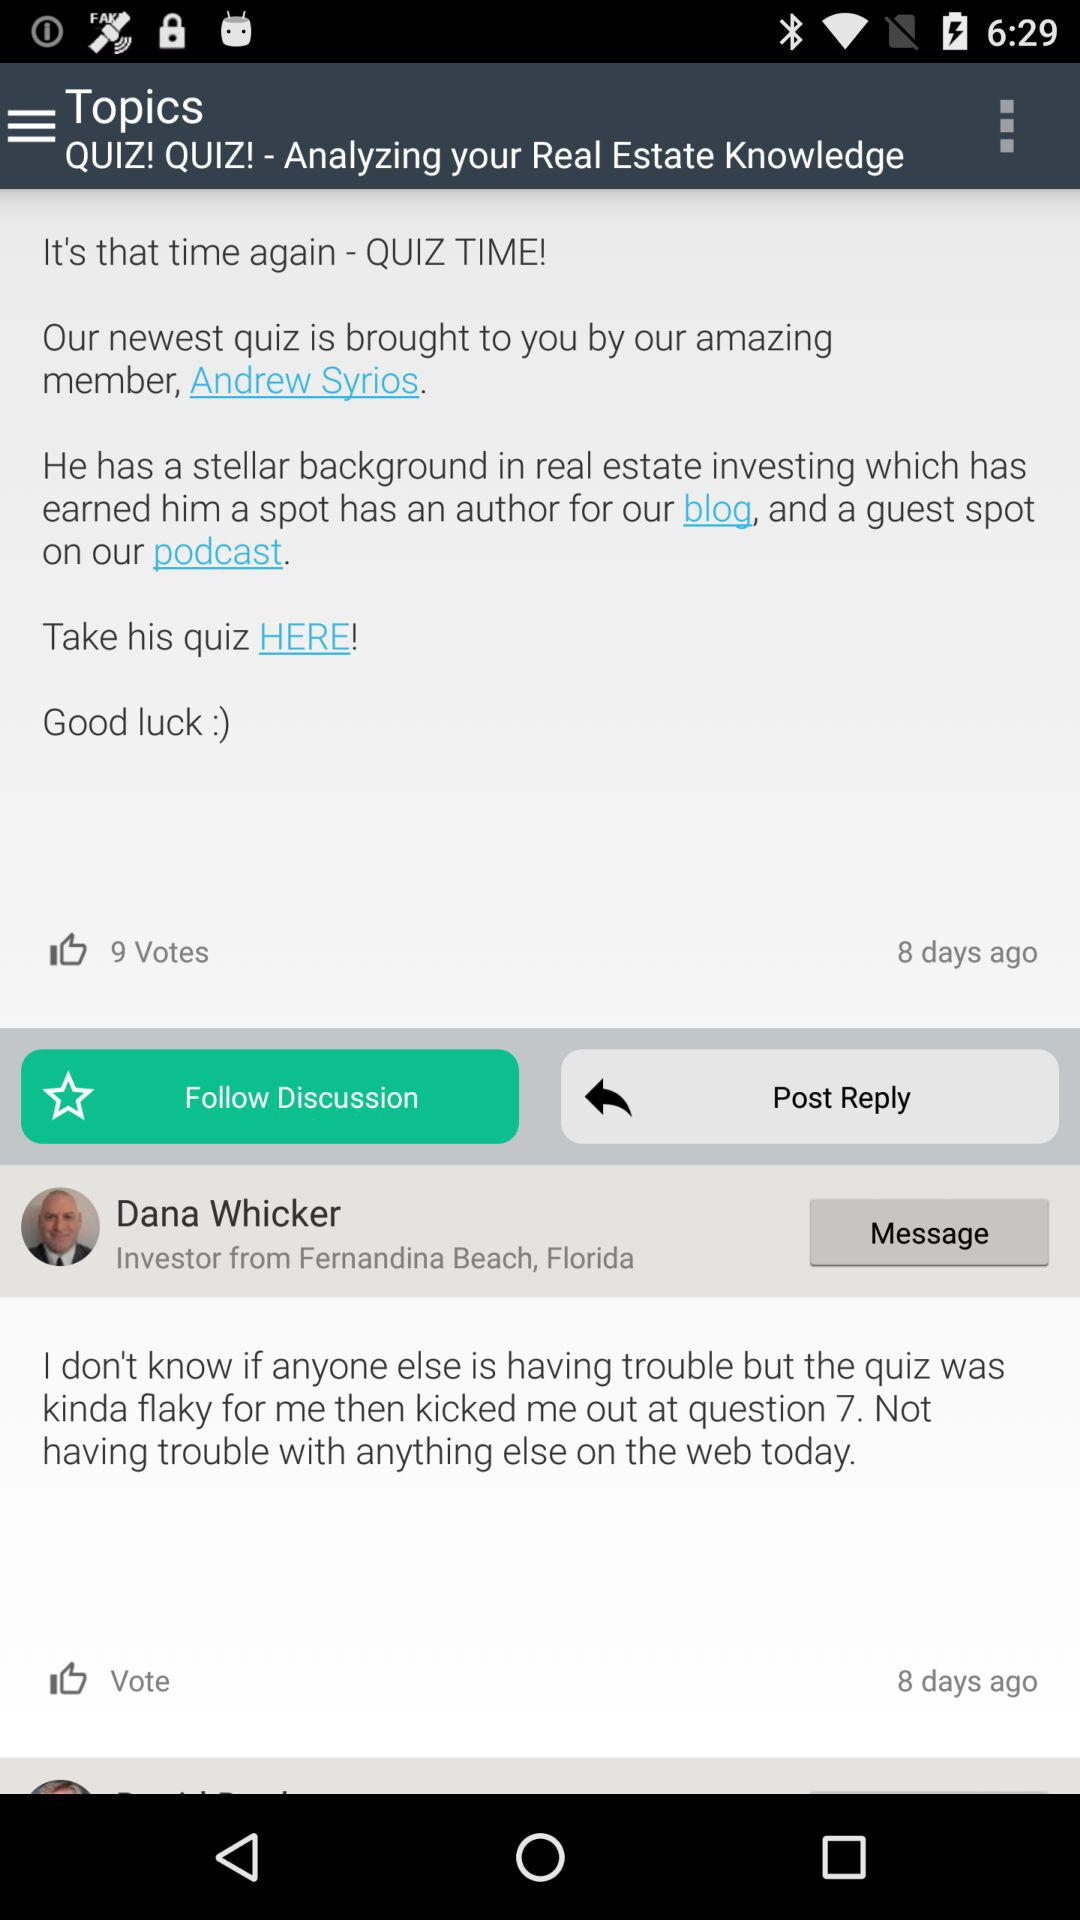By whom is our newest quiz brought to us? Our newest quiz is brought to us by Andrew Syrios. 